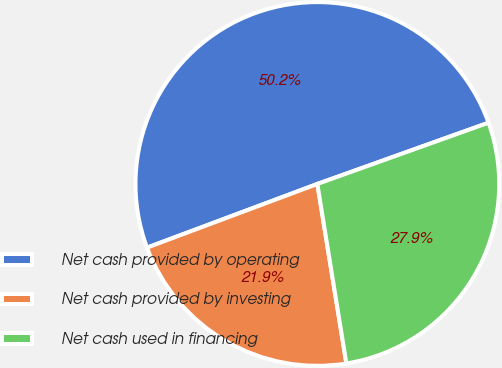Convert chart. <chart><loc_0><loc_0><loc_500><loc_500><pie_chart><fcel>Net cash provided by operating<fcel>Net cash provided by investing<fcel>Net cash used in financing<nl><fcel>50.23%<fcel>21.86%<fcel>27.92%<nl></chart> 